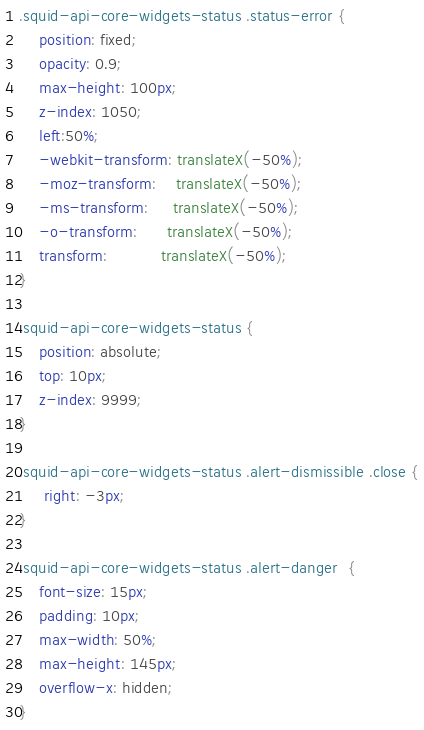<code> <loc_0><loc_0><loc_500><loc_500><_CSS_>.squid-api-core-widgets-status .status-error {
   	position: fixed;
   	opacity: 0.9;
    max-height: 100px;
   	z-index: 1050;
   	left:50%;
   	-webkit-transform: translateX(-50%);
  	-moz-transform:    translateX(-50%);
  	-ms-transform:     translateX(-50%);
  	-o-transform:      translateX(-50%);
   	transform: 		   translateX(-50%);
}

.squid-api-core-widgets-status {
	position: absolute;
  	top: 10px;
    z-index: 9999;
}

.squid-api-core-widgets-status .alert-dismissible .close {
	 right: -3px;
}

.squid-api-core-widgets-status .alert-danger  {
    font-size: 15px;
    padding: 10px;
    max-width: 50%;
    max-height: 145px;
    overflow-x: hidden;
}
</code> 